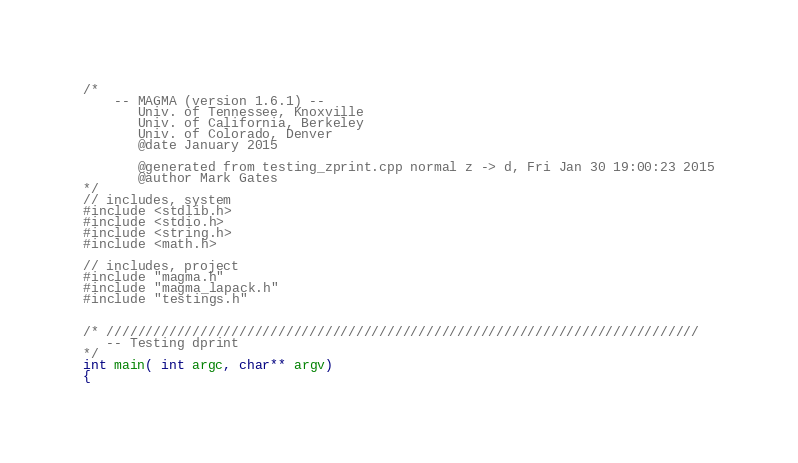Convert code to text. <code><loc_0><loc_0><loc_500><loc_500><_C++_>/*
    -- MAGMA (version 1.6.1) --
       Univ. of Tennessee, Knoxville
       Univ. of California, Berkeley
       Univ. of Colorado, Denver
       @date January 2015
  
       @generated from testing_zprint.cpp normal z -> d, Fri Jan 30 19:00:23 2015
       @author Mark Gates
*/
// includes, system
#include <stdlib.h>
#include <stdio.h>
#include <string.h>
#include <math.h>

// includes, project
#include "magma.h"
#include "magma_lapack.h"
#include "testings.h"


/* ////////////////////////////////////////////////////////////////////////////
   -- Testing dprint
*/
int main( int argc, char** argv)
{</code> 